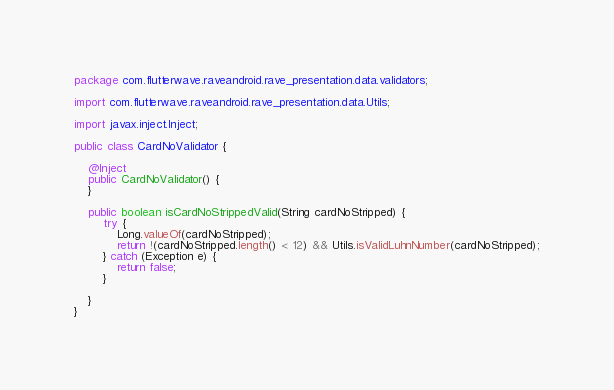Convert code to text. <code><loc_0><loc_0><loc_500><loc_500><_Java_>package com.flutterwave.raveandroid.rave_presentation.data.validators;

import com.flutterwave.raveandroid.rave_presentation.data.Utils;

import javax.inject.Inject;

public class CardNoValidator {

    @Inject
    public CardNoValidator() {
    }

    public boolean isCardNoStrippedValid(String cardNoStripped) {
        try {
            Long.valueOf(cardNoStripped);
            return !(cardNoStripped.length() < 12) && Utils.isValidLuhnNumber(cardNoStripped);
        } catch (Exception e) {
            return false;
        }

    }
}
</code> 